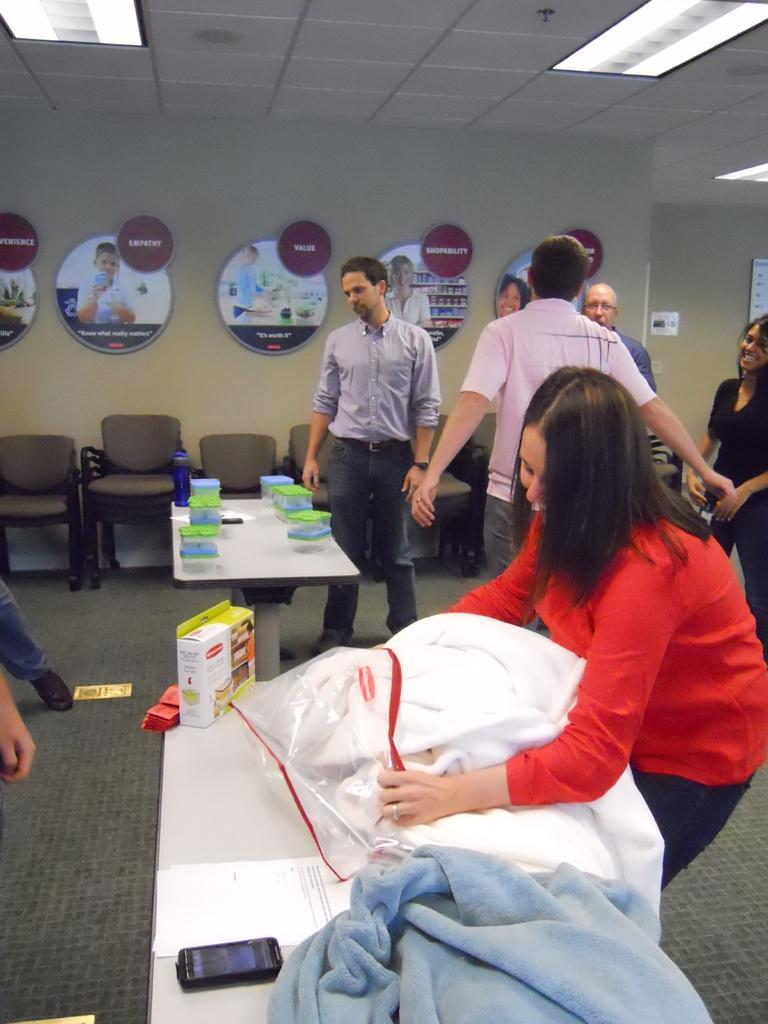How many people are in the group visible in the image? There is a group of people standing in the image, but the exact number cannot be determined from the provided facts. What is on the table in the image? There is a table in the image, and there are boxes on the table. What else can be seen on the table besides the boxes? There are objects visible on the table, but their specific nature cannot be determined from the provided facts. What is the background of the image? There is a wall in the image, which suggests that the background is an indoor setting. What type of lighting is present in the image? There is a light in the image, but its specific type or intensity cannot be determined from the provided facts. Can you see any buckets in the garden in the image? There is no garden or bucket present in the image. What type of headwear is the person in the image wearing? There is no mention of any person wearing headwear in the provided facts. 